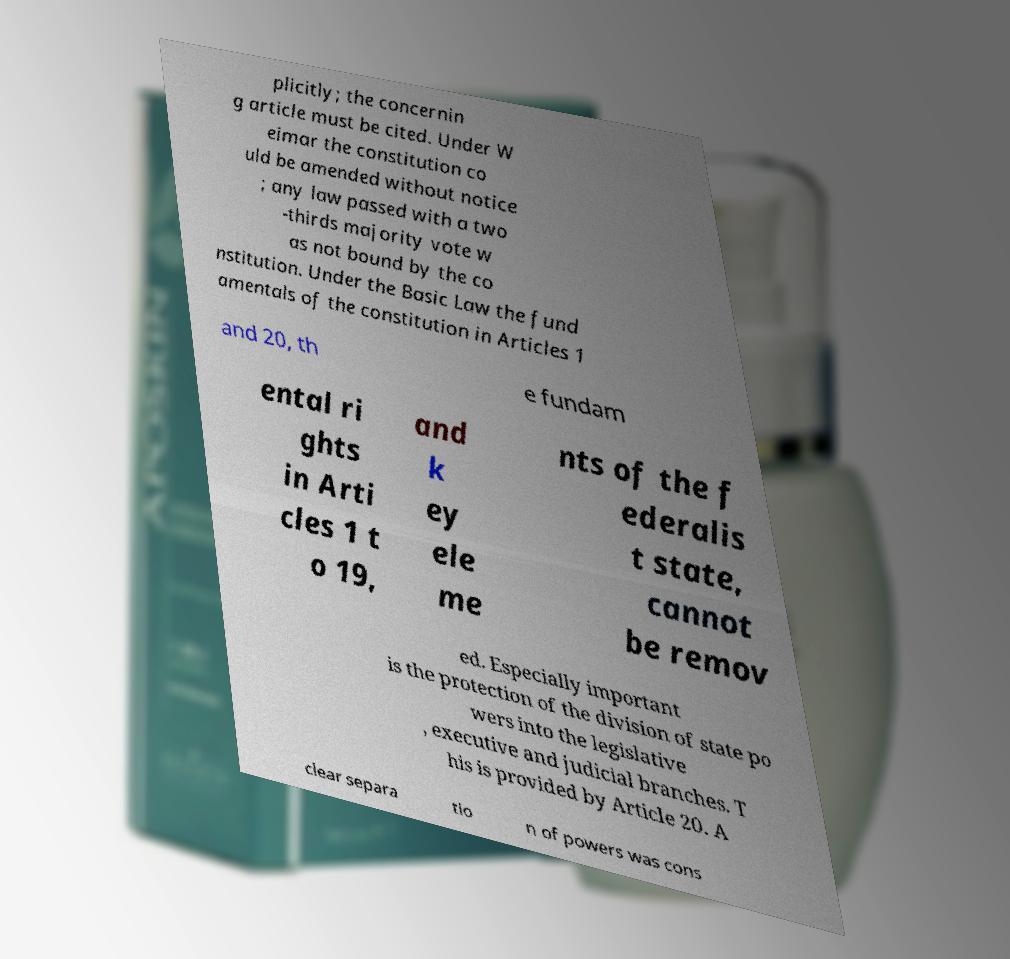Can you accurately transcribe the text from the provided image for me? plicitly; the concernin g article must be cited. Under W eimar the constitution co uld be amended without notice ; any law passed with a two -thirds majority vote w as not bound by the co nstitution. Under the Basic Law the fund amentals of the constitution in Articles 1 and 20, th e fundam ental ri ghts in Arti cles 1 t o 19, and k ey ele me nts of the f ederalis t state, cannot be remov ed. Especially important is the protection of the division of state po wers into the legislative , executive and judicial branches. T his is provided by Article 20. A clear separa tio n of powers was cons 